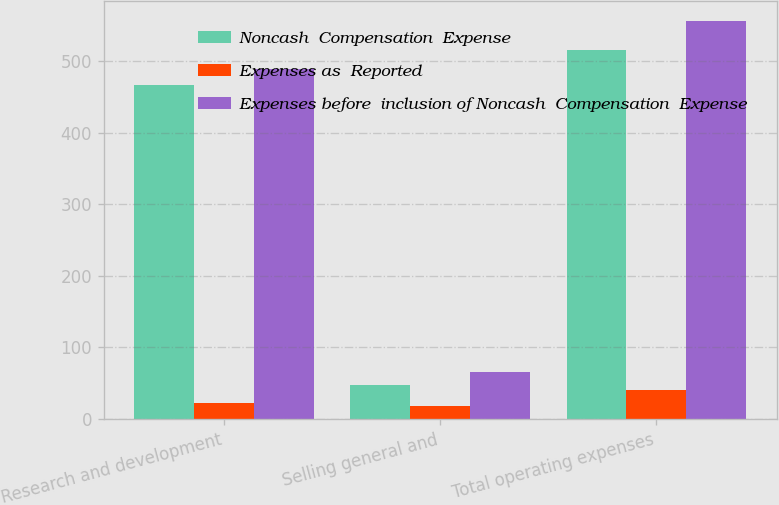Convert chart. <chart><loc_0><loc_0><loc_500><loc_500><stacked_bar_chart><ecel><fcel>Research and development<fcel>Selling general and<fcel>Total operating expenses<nl><fcel>Noncash  Compensation  Expense<fcel>466.9<fcel>47.6<fcel>516.6<nl><fcel>Expenses as  Reported<fcel>22.3<fcel>17.6<fcel>39.9<nl><fcel>Expenses before  inclusion of Noncash  Compensation  Expense<fcel>489.2<fcel>65.2<fcel>556.5<nl></chart> 